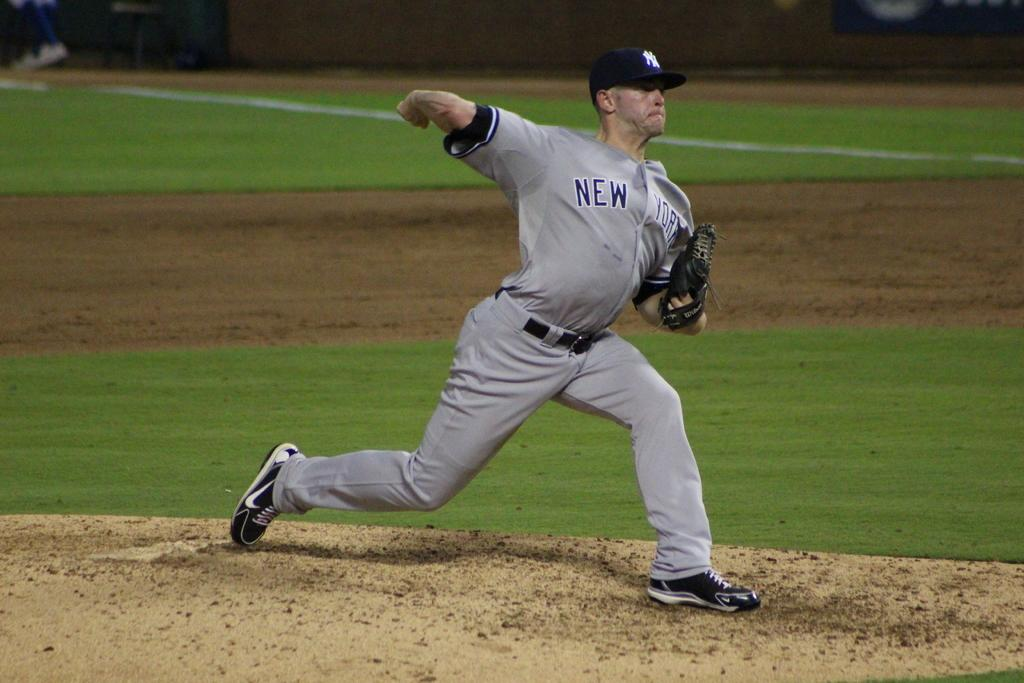Provide a one-sentence caption for the provided image. A New York baseball team pitcher is in the bowling action. 